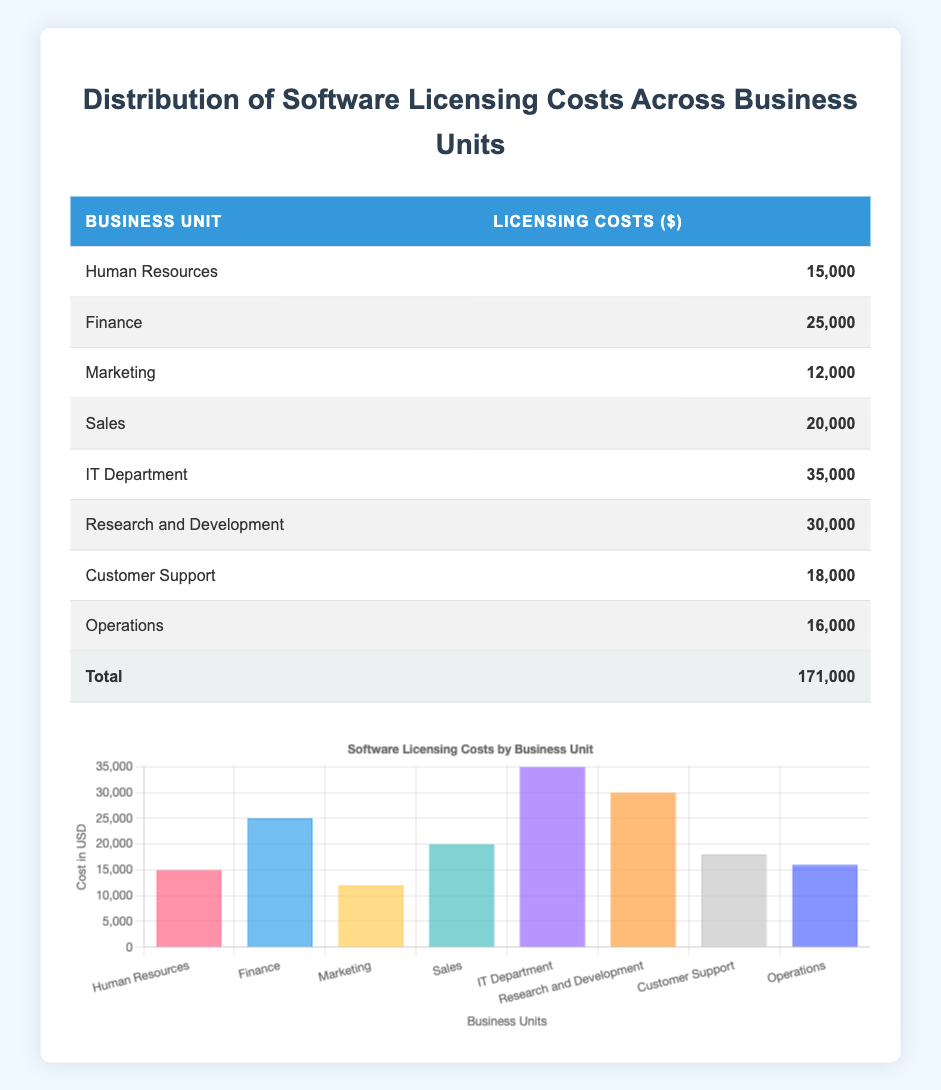What is the software licensing cost for the IT Department? The IT Department is listed in the table, and its software licensing cost is directly provided alongside it. The value for the IT Department is 35,000 dollars.
Answer: 35,000 Which business unit has the highest software licensing cost? By looking at the licensing costs of each business unit, I can see that the IT Department has the highest cost at 35,000 dollars, compared to all other units listed.
Answer: IT Department What is the total software licensing cost for all business units? I sum the software licensing costs of each unit as follows: 15,000 (HR) + 25,000 (Finance) + 12,000 (Marketing) + 20,000 (Sales) + 35,000 (IT) + 30,000 (R&D) + 18,000 (Customer Support) + 16,000 (Operations) = 171,000 dollars. The total is clearly stated in the last row of the table.
Answer: 171,000 What is the average software licensing cost across all business units? To find the average, I first add up all the software licensing costs, which totals to 171,000 dollars (as previously calculated). Next, I divide this sum by the number of business units, which is 8. Thus, the average cost is 171,000 / 8 = 21,375 dollars.
Answer: 21,375 Is the software licensing cost for Customer Support greater than that of Marketing? Looking at the table, Customer Support has a licensing cost of 18,000 dollars, while Marketing has a cost of 12,000 dollars. Since 18,000 is greater than 12,000, the statement is true.
Answer: Yes How much more does the IT Department spend on software licensing than Marketing? The IT Department has a cost of 35,000 dollars and Marketing has a cost of 12,000 dollars. Subtracting the latter from the former gives 35,000 - 12,000 = 23,000 dollars. Therefore, the IT Department spends 23,000 dollars more than Marketing.
Answer: 23,000 Are there more business units with software licensing costs above 20,000 dollars than below? Counting the costs, the units that have costs above 20,000 dollars are Finance (25,000), IT Department (35,000), and Research and Development (30,000). That totals to 3 units. The units below 20,000 are Human Resources (15,000), Marketing (12,000), Customer Support (18,000), and Operations (16,000), totaling 4 units. Therefore, 3 units are above and 4 units are below, making the statement false.
Answer: No What is the difference in licensing costs between the highest and lowest business units? The highest licensing cost is for the IT Department at 35,000 dollars and the lowest is for Marketing at 12,000 dollars. To find the difference, I subtract 12,000 from 35,000, resulting in 35,000 - 12,000 = 23,000 dollars.
Answer: 23,000 